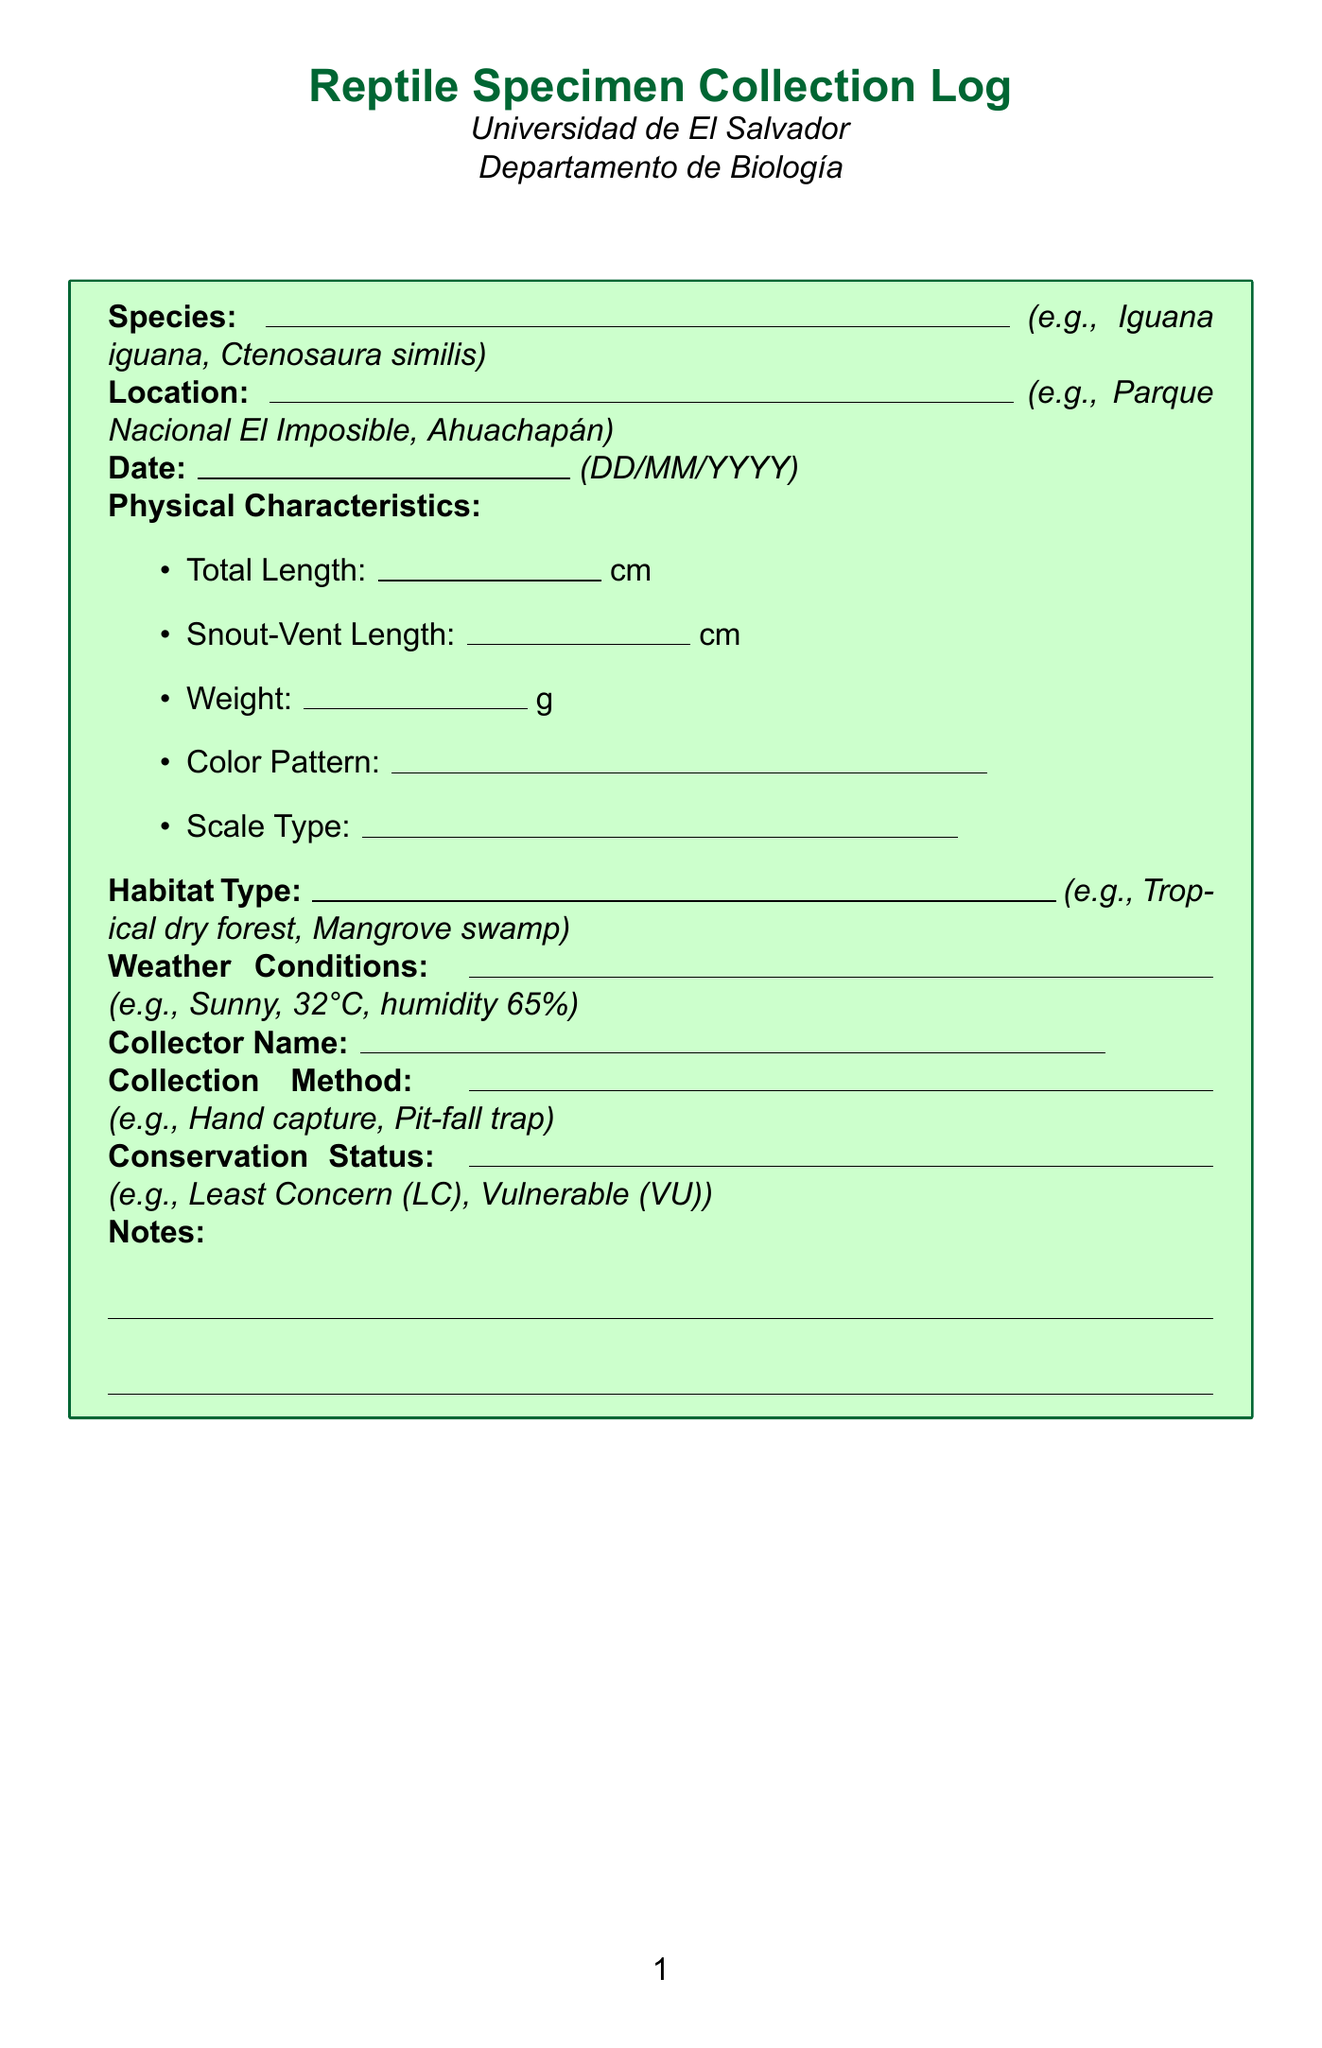What is the title of the form? The title is displayed prominently at the top of the document as "Reptile Specimen Collection Log."
Answer: Reptile Specimen Collection Log Which institution is associated with the document? The institution name is listed below the title as "Universidad de El Salvador."
Answer: Universidad de El Salvador What is the date format used in the document? The document specifies the date format as DD/MM/YYYY for specimen collection.
Answer: DD/MM/YYYY What unit is used for the weight of the specimen? The unit for weight is indicated as 'g' (grams) in the Physical Characteristics section.
Answer: g Which weather condition is described as an example in the document? An example of weather conditions provided in the document includes "Sunny, 32°C, humidity 65%."
Answer: Sunny, 32°C, humidity 65% What type of habitat is specifically mentioned as an example? The habitat type is described with examples, one of which is "Tropical dry forest."
Answer: Tropical dry forest What is the conservation status of the species that can be recorded? The conservation status categories are stated, for example, "Least Concern (LC)."
Answer: Least Concern (LC) What is one method listed for collecting specimens? The document provides examples, one being "Hand capture."
Answer: Hand capture Who is responsible for collecting the specimen? The document includes a field for the name of the collector, such as "Dr. María Elena Rodríguez."
Answer: Dr. María Elena Rodríguez 